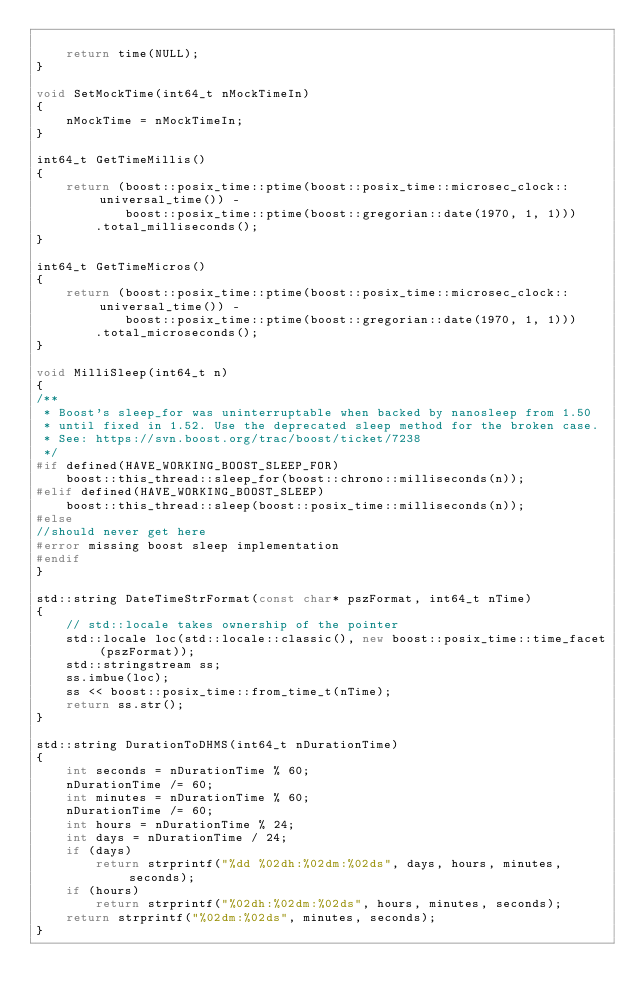Convert code to text. <code><loc_0><loc_0><loc_500><loc_500><_C++_>
    return time(NULL);
}

void SetMockTime(int64_t nMockTimeIn)
{
    nMockTime = nMockTimeIn;
}

int64_t GetTimeMillis()
{
    return (boost::posix_time::ptime(boost::posix_time::microsec_clock::universal_time()) -
            boost::posix_time::ptime(boost::gregorian::date(1970, 1, 1)))
        .total_milliseconds();
}

int64_t GetTimeMicros()
{
    return (boost::posix_time::ptime(boost::posix_time::microsec_clock::universal_time()) -
            boost::posix_time::ptime(boost::gregorian::date(1970, 1, 1)))
        .total_microseconds();
}

void MilliSleep(int64_t n)
{
/**
 * Boost's sleep_for was uninterruptable when backed by nanosleep from 1.50
 * until fixed in 1.52. Use the deprecated sleep method for the broken case.
 * See: https://svn.boost.org/trac/boost/ticket/7238
 */
#if defined(HAVE_WORKING_BOOST_SLEEP_FOR)
    boost::this_thread::sleep_for(boost::chrono::milliseconds(n));
#elif defined(HAVE_WORKING_BOOST_SLEEP)
    boost::this_thread::sleep(boost::posix_time::milliseconds(n));
#else
//should never get here
#error missing boost sleep implementation
#endif
}

std::string DateTimeStrFormat(const char* pszFormat, int64_t nTime)
{
    // std::locale takes ownership of the pointer
    std::locale loc(std::locale::classic(), new boost::posix_time::time_facet(pszFormat));
    std::stringstream ss;
    ss.imbue(loc);
    ss << boost::posix_time::from_time_t(nTime);
    return ss.str();
}

std::string DurationToDHMS(int64_t nDurationTime)
{
    int seconds = nDurationTime % 60;
    nDurationTime /= 60;
    int minutes = nDurationTime % 60;
    nDurationTime /= 60;
    int hours = nDurationTime % 24;
    int days = nDurationTime / 24;
    if (days)
        return strprintf("%dd %02dh:%02dm:%02ds", days, hours, minutes, seconds);
    if (hours)
        return strprintf("%02dh:%02dm:%02ds", hours, minutes, seconds);
    return strprintf("%02dm:%02ds", minutes, seconds);
}
</code> 